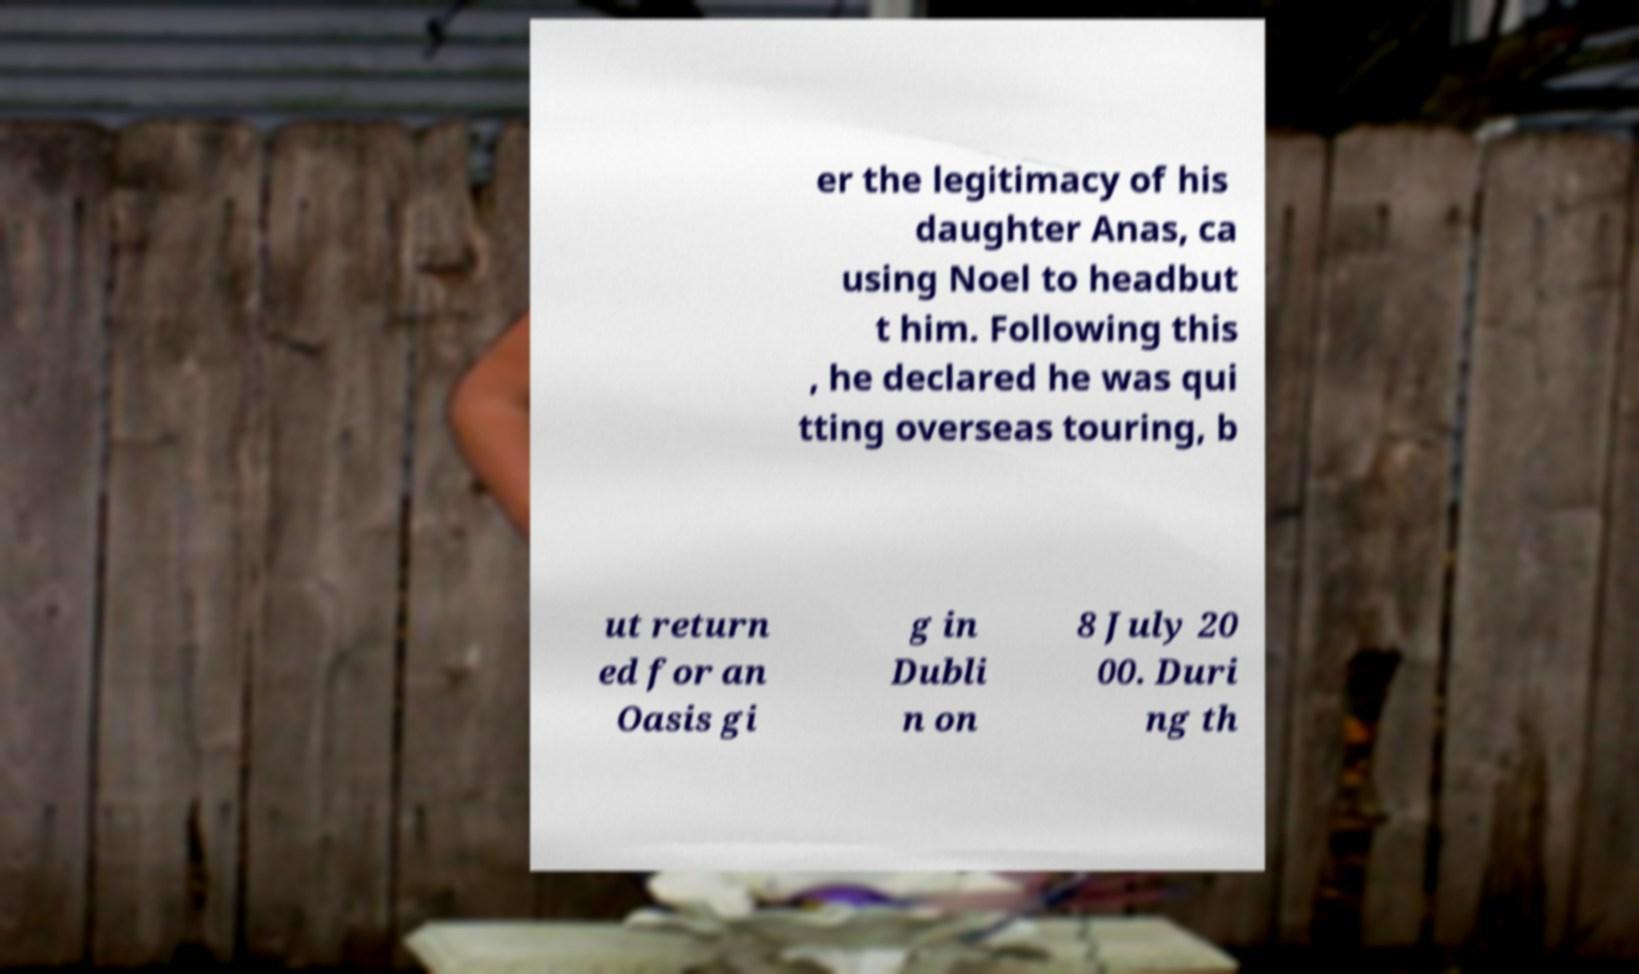There's text embedded in this image that I need extracted. Can you transcribe it verbatim? er the legitimacy of his daughter Anas, ca using Noel to headbut t him. Following this , he declared he was qui tting overseas touring, b ut return ed for an Oasis gi g in Dubli n on 8 July 20 00. Duri ng th 